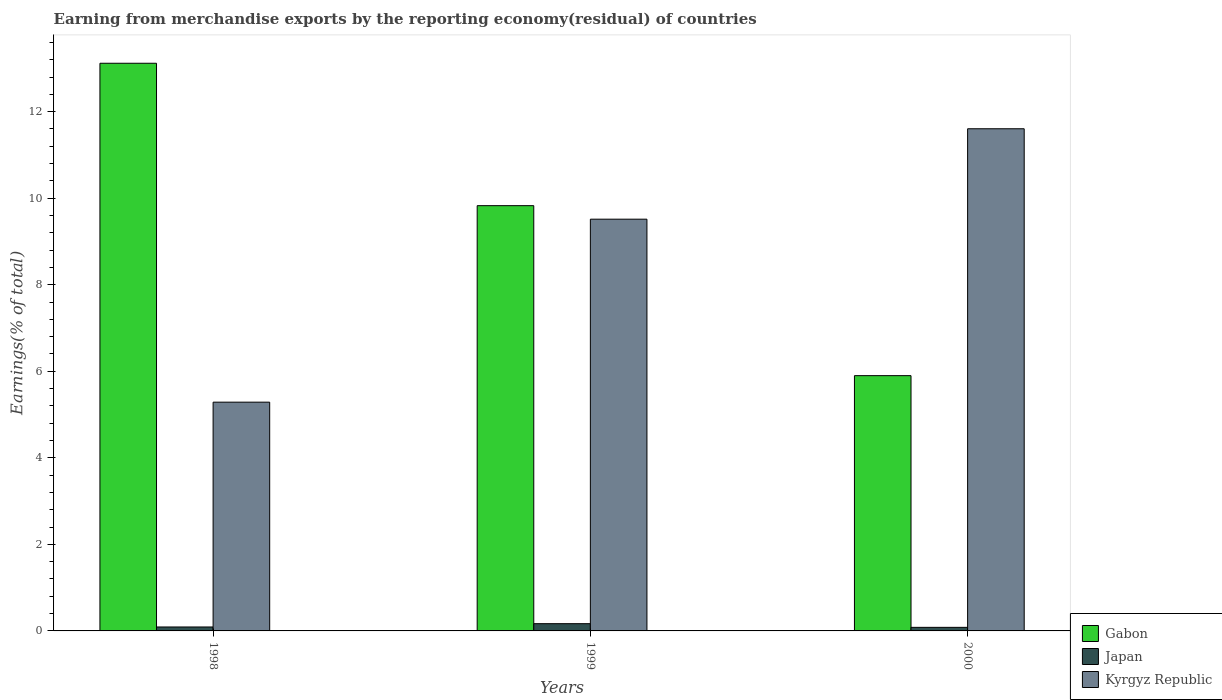How many different coloured bars are there?
Your answer should be very brief. 3. How many groups of bars are there?
Offer a very short reply. 3. Are the number of bars on each tick of the X-axis equal?
Keep it short and to the point. Yes. How many bars are there on the 2nd tick from the right?
Provide a short and direct response. 3. What is the percentage of amount earned from merchandise exports in Japan in 1999?
Give a very brief answer. 0.17. Across all years, what is the maximum percentage of amount earned from merchandise exports in Kyrgyz Republic?
Offer a very short reply. 11.61. Across all years, what is the minimum percentage of amount earned from merchandise exports in Gabon?
Give a very brief answer. 5.9. What is the total percentage of amount earned from merchandise exports in Gabon in the graph?
Your answer should be very brief. 28.85. What is the difference between the percentage of amount earned from merchandise exports in Japan in 1999 and that in 2000?
Offer a very short reply. 0.08. What is the difference between the percentage of amount earned from merchandise exports in Japan in 2000 and the percentage of amount earned from merchandise exports in Kyrgyz Republic in 1999?
Provide a short and direct response. -9.43. What is the average percentage of amount earned from merchandise exports in Gabon per year?
Offer a terse response. 9.62. In the year 2000, what is the difference between the percentage of amount earned from merchandise exports in Gabon and percentage of amount earned from merchandise exports in Japan?
Provide a succinct answer. 5.82. In how many years, is the percentage of amount earned from merchandise exports in Japan greater than 10 %?
Ensure brevity in your answer.  0. What is the ratio of the percentage of amount earned from merchandise exports in Kyrgyz Republic in 1998 to that in 2000?
Ensure brevity in your answer.  0.46. Is the difference between the percentage of amount earned from merchandise exports in Gabon in 1998 and 2000 greater than the difference between the percentage of amount earned from merchandise exports in Japan in 1998 and 2000?
Your response must be concise. Yes. What is the difference between the highest and the second highest percentage of amount earned from merchandise exports in Japan?
Offer a terse response. 0.08. What is the difference between the highest and the lowest percentage of amount earned from merchandise exports in Gabon?
Your answer should be compact. 7.22. Is the sum of the percentage of amount earned from merchandise exports in Gabon in 1999 and 2000 greater than the maximum percentage of amount earned from merchandise exports in Japan across all years?
Offer a very short reply. Yes. What does the 2nd bar from the left in 1999 represents?
Offer a very short reply. Japan. What does the 2nd bar from the right in 2000 represents?
Keep it short and to the point. Japan. How many bars are there?
Provide a succinct answer. 9. How many years are there in the graph?
Ensure brevity in your answer.  3. Does the graph contain grids?
Your answer should be very brief. No. Where does the legend appear in the graph?
Your answer should be compact. Bottom right. How many legend labels are there?
Provide a short and direct response. 3. How are the legend labels stacked?
Provide a succinct answer. Vertical. What is the title of the graph?
Give a very brief answer. Earning from merchandise exports by the reporting economy(residual) of countries. What is the label or title of the Y-axis?
Provide a short and direct response. Earnings(% of total). What is the Earnings(% of total) of Gabon in 1998?
Provide a short and direct response. 13.12. What is the Earnings(% of total) in Japan in 1998?
Provide a short and direct response. 0.09. What is the Earnings(% of total) of Kyrgyz Republic in 1998?
Your answer should be compact. 5.29. What is the Earnings(% of total) of Gabon in 1999?
Your answer should be very brief. 9.83. What is the Earnings(% of total) in Japan in 1999?
Keep it short and to the point. 0.17. What is the Earnings(% of total) of Kyrgyz Republic in 1999?
Your answer should be compact. 9.52. What is the Earnings(% of total) in Gabon in 2000?
Provide a succinct answer. 5.9. What is the Earnings(% of total) of Japan in 2000?
Your response must be concise. 0.08. What is the Earnings(% of total) in Kyrgyz Republic in 2000?
Give a very brief answer. 11.61. Across all years, what is the maximum Earnings(% of total) of Gabon?
Your answer should be compact. 13.12. Across all years, what is the maximum Earnings(% of total) of Japan?
Make the answer very short. 0.17. Across all years, what is the maximum Earnings(% of total) in Kyrgyz Republic?
Offer a terse response. 11.61. Across all years, what is the minimum Earnings(% of total) in Gabon?
Your response must be concise. 5.9. Across all years, what is the minimum Earnings(% of total) in Japan?
Offer a very short reply. 0.08. Across all years, what is the minimum Earnings(% of total) in Kyrgyz Republic?
Keep it short and to the point. 5.29. What is the total Earnings(% of total) of Gabon in the graph?
Make the answer very short. 28.85. What is the total Earnings(% of total) in Japan in the graph?
Provide a short and direct response. 0.34. What is the total Earnings(% of total) of Kyrgyz Republic in the graph?
Your response must be concise. 26.41. What is the difference between the Earnings(% of total) in Gabon in 1998 and that in 1999?
Give a very brief answer. 3.29. What is the difference between the Earnings(% of total) of Japan in 1998 and that in 1999?
Your answer should be compact. -0.08. What is the difference between the Earnings(% of total) in Kyrgyz Republic in 1998 and that in 1999?
Offer a terse response. -4.23. What is the difference between the Earnings(% of total) of Gabon in 1998 and that in 2000?
Your answer should be compact. 7.22. What is the difference between the Earnings(% of total) in Japan in 1998 and that in 2000?
Make the answer very short. 0.01. What is the difference between the Earnings(% of total) in Kyrgyz Republic in 1998 and that in 2000?
Give a very brief answer. -6.32. What is the difference between the Earnings(% of total) in Gabon in 1999 and that in 2000?
Provide a short and direct response. 3.93. What is the difference between the Earnings(% of total) in Japan in 1999 and that in 2000?
Your answer should be very brief. 0.09. What is the difference between the Earnings(% of total) in Kyrgyz Republic in 1999 and that in 2000?
Offer a very short reply. -2.09. What is the difference between the Earnings(% of total) of Gabon in 1998 and the Earnings(% of total) of Japan in 1999?
Your response must be concise. 12.95. What is the difference between the Earnings(% of total) of Gabon in 1998 and the Earnings(% of total) of Kyrgyz Republic in 1999?
Make the answer very short. 3.6. What is the difference between the Earnings(% of total) of Japan in 1998 and the Earnings(% of total) of Kyrgyz Republic in 1999?
Keep it short and to the point. -9.42. What is the difference between the Earnings(% of total) of Gabon in 1998 and the Earnings(% of total) of Japan in 2000?
Provide a short and direct response. 13.04. What is the difference between the Earnings(% of total) of Gabon in 1998 and the Earnings(% of total) of Kyrgyz Republic in 2000?
Your response must be concise. 1.51. What is the difference between the Earnings(% of total) in Japan in 1998 and the Earnings(% of total) in Kyrgyz Republic in 2000?
Your answer should be compact. -11.51. What is the difference between the Earnings(% of total) of Gabon in 1999 and the Earnings(% of total) of Japan in 2000?
Give a very brief answer. 9.75. What is the difference between the Earnings(% of total) in Gabon in 1999 and the Earnings(% of total) in Kyrgyz Republic in 2000?
Offer a very short reply. -1.78. What is the difference between the Earnings(% of total) of Japan in 1999 and the Earnings(% of total) of Kyrgyz Republic in 2000?
Your answer should be very brief. -11.44. What is the average Earnings(% of total) of Gabon per year?
Offer a very short reply. 9.62. What is the average Earnings(% of total) of Japan per year?
Provide a short and direct response. 0.11. What is the average Earnings(% of total) of Kyrgyz Republic per year?
Your response must be concise. 8.8. In the year 1998, what is the difference between the Earnings(% of total) in Gabon and Earnings(% of total) in Japan?
Ensure brevity in your answer.  13.03. In the year 1998, what is the difference between the Earnings(% of total) of Gabon and Earnings(% of total) of Kyrgyz Republic?
Make the answer very short. 7.83. In the year 1998, what is the difference between the Earnings(% of total) of Japan and Earnings(% of total) of Kyrgyz Republic?
Give a very brief answer. -5.2. In the year 1999, what is the difference between the Earnings(% of total) in Gabon and Earnings(% of total) in Japan?
Offer a terse response. 9.66. In the year 1999, what is the difference between the Earnings(% of total) in Gabon and Earnings(% of total) in Kyrgyz Republic?
Your response must be concise. 0.31. In the year 1999, what is the difference between the Earnings(% of total) in Japan and Earnings(% of total) in Kyrgyz Republic?
Your answer should be compact. -9.35. In the year 2000, what is the difference between the Earnings(% of total) in Gabon and Earnings(% of total) in Japan?
Offer a very short reply. 5.82. In the year 2000, what is the difference between the Earnings(% of total) in Gabon and Earnings(% of total) in Kyrgyz Republic?
Your response must be concise. -5.71. In the year 2000, what is the difference between the Earnings(% of total) of Japan and Earnings(% of total) of Kyrgyz Republic?
Provide a succinct answer. -11.52. What is the ratio of the Earnings(% of total) in Gabon in 1998 to that in 1999?
Give a very brief answer. 1.33. What is the ratio of the Earnings(% of total) in Japan in 1998 to that in 1999?
Make the answer very short. 0.54. What is the ratio of the Earnings(% of total) of Kyrgyz Republic in 1998 to that in 1999?
Offer a very short reply. 0.56. What is the ratio of the Earnings(% of total) of Gabon in 1998 to that in 2000?
Make the answer very short. 2.22. What is the ratio of the Earnings(% of total) in Japan in 1998 to that in 2000?
Your answer should be compact. 1.1. What is the ratio of the Earnings(% of total) in Kyrgyz Republic in 1998 to that in 2000?
Make the answer very short. 0.46. What is the ratio of the Earnings(% of total) in Gabon in 1999 to that in 2000?
Give a very brief answer. 1.67. What is the ratio of the Earnings(% of total) of Japan in 1999 to that in 2000?
Make the answer very short. 2.03. What is the ratio of the Earnings(% of total) in Kyrgyz Republic in 1999 to that in 2000?
Provide a succinct answer. 0.82. What is the difference between the highest and the second highest Earnings(% of total) in Gabon?
Offer a very short reply. 3.29. What is the difference between the highest and the second highest Earnings(% of total) of Japan?
Give a very brief answer. 0.08. What is the difference between the highest and the second highest Earnings(% of total) in Kyrgyz Republic?
Provide a succinct answer. 2.09. What is the difference between the highest and the lowest Earnings(% of total) in Gabon?
Provide a short and direct response. 7.22. What is the difference between the highest and the lowest Earnings(% of total) in Japan?
Ensure brevity in your answer.  0.09. What is the difference between the highest and the lowest Earnings(% of total) in Kyrgyz Republic?
Your response must be concise. 6.32. 